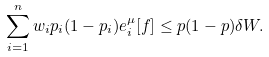<formula> <loc_0><loc_0><loc_500><loc_500>\sum _ { i = 1 } ^ { n } w _ { i } p _ { i } ( 1 - p _ { i } ) e _ { i } ^ { \mu } [ f ] \leq p ( 1 - p ) \delta W .</formula> 